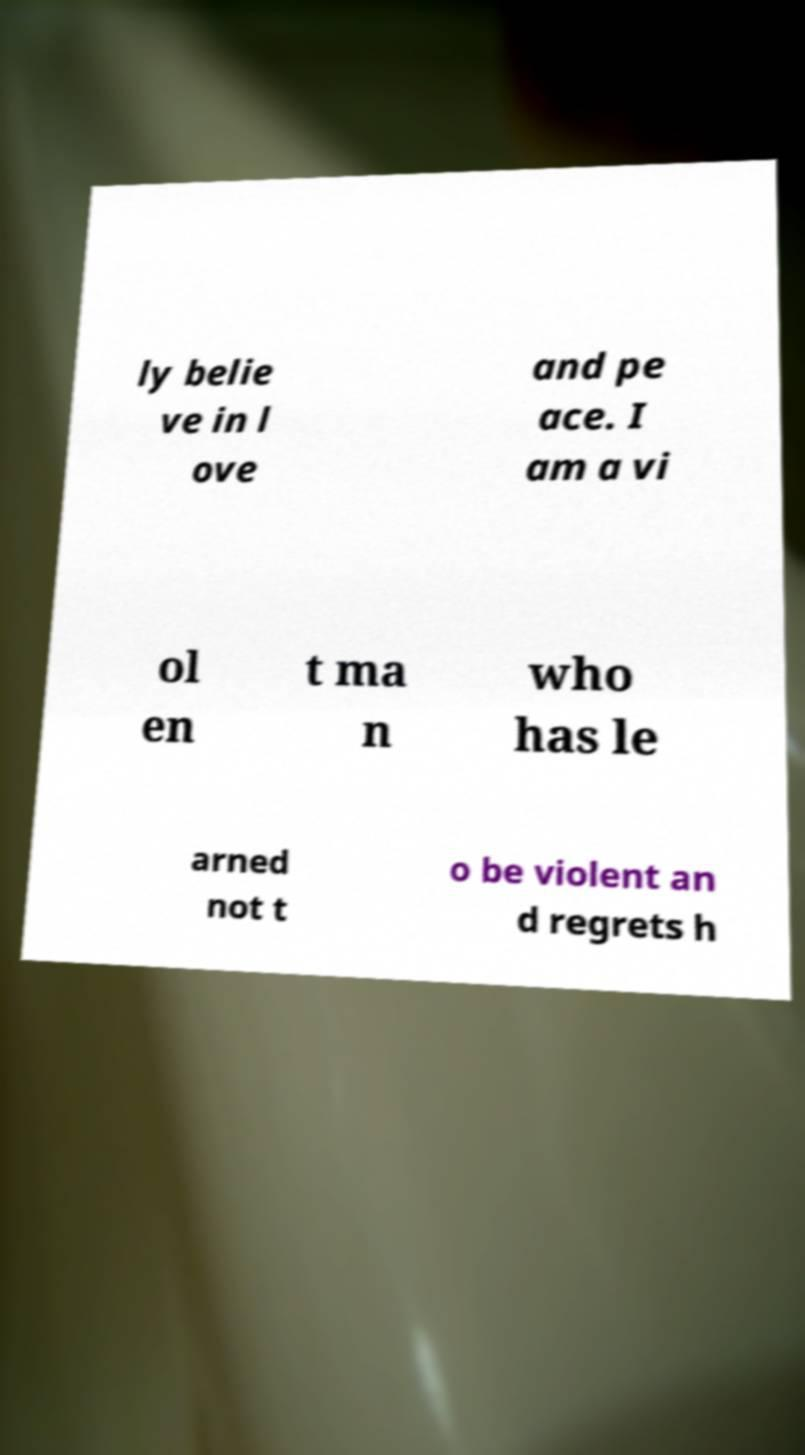Please read and relay the text visible in this image. What does it say? ly belie ve in l ove and pe ace. I am a vi ol en t ma n who has le arned not t o be violent an d regrets h 